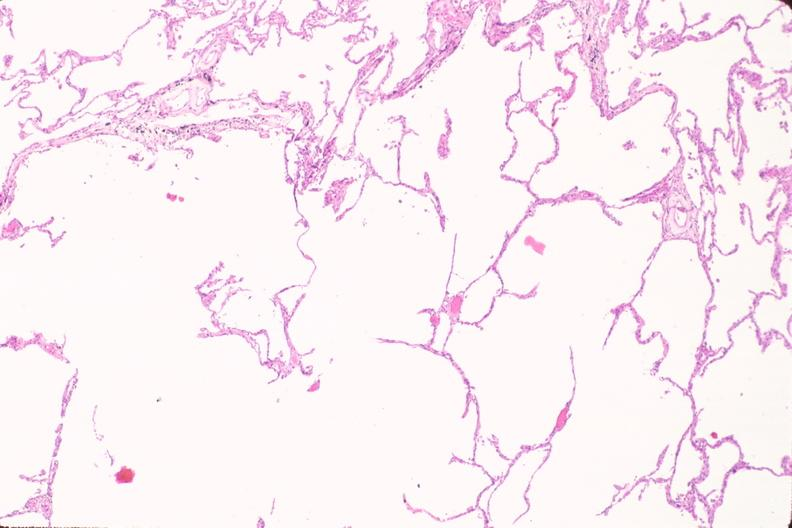what does this image show?
Answer the question using a single word or phrase. Lung 